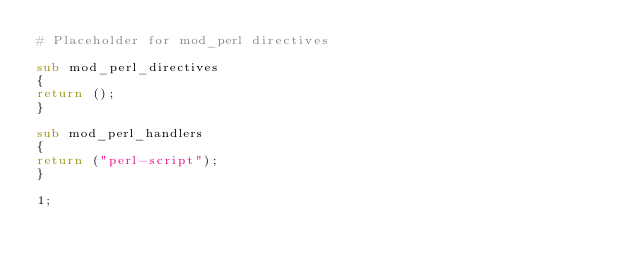Convert code to text. <code><loc_0><loc_0><loc_500><loc_500><_Perl_># Placeholder for mod_perl directives

sub mod_perl_directives
{
return ();
}

sub mod_perl_handlers
{
return ("perl-script");
}

1;
</code> 